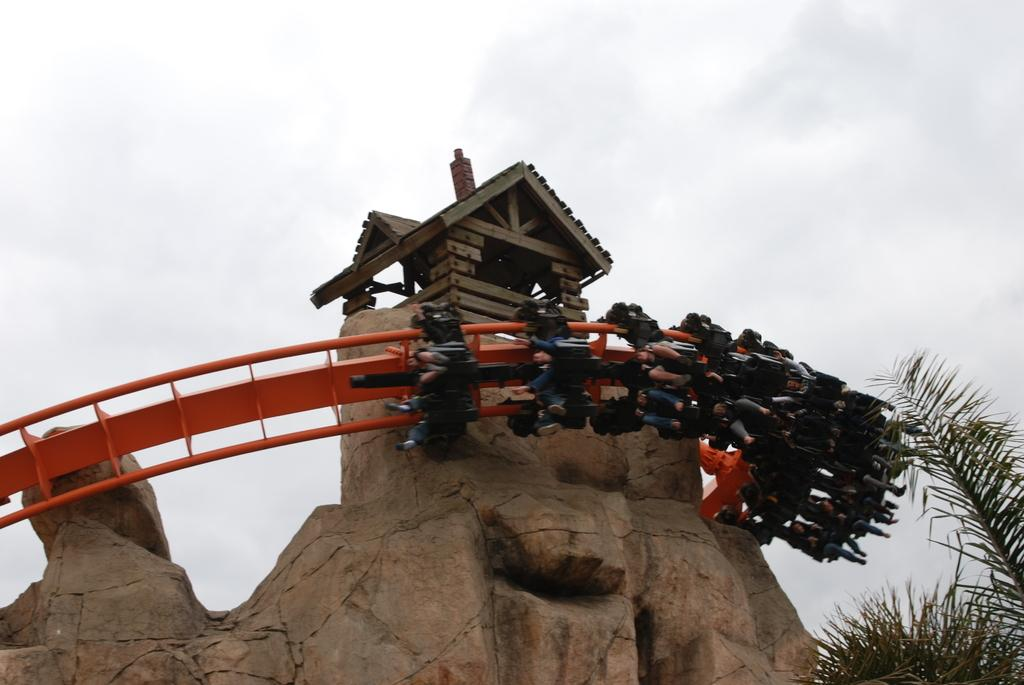What are the people in the image doing? The people are riding a roller coaster in the image. What can be seen in the background of the image? There are trees and the sky visible in the background of the image. What type of structure is present in the image? There is a small wooden house in the image. Where is the nest of the fish in the image? There is no nest or fish present in the image. What type of harmony can be observed among the people in the image? The image does not provide information about the emotional state or harmony among the people riding the roller coaster. 